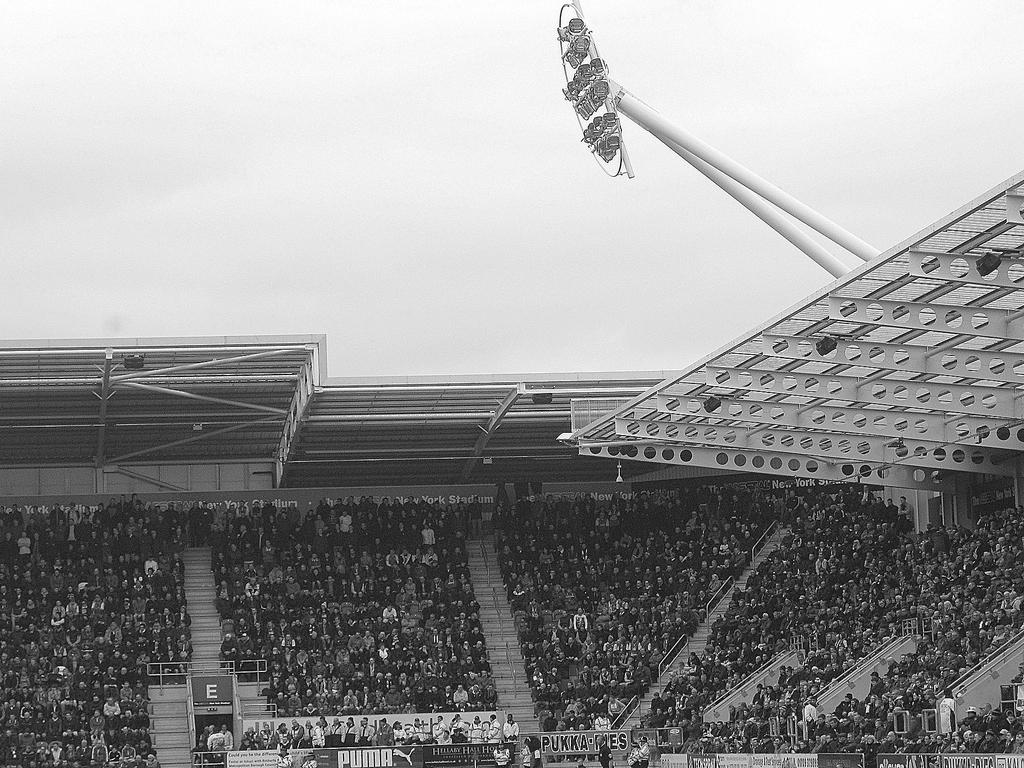What is the color scheme of the image? The image is black and white. What can be seen in the image? There is a group of people, chairs, stairs, poles, name boards, and lights in the image. Can you describe the setting of the image? The image features a group of people in a location with chairs, stairs, and poles, along with name boards and lights. The sky is visible in the background. What type of steel is used to construct the wheel in the image? There is no wheel present in the image, so it is not possible to determine the type of steel used in its construction. 